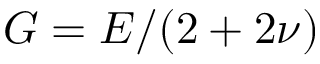Convert formula to latex. <formula><loc_0><loc_0><loc_500><loc_500>{ G = E / ( 2 + 2 \nu ) }</formula> 